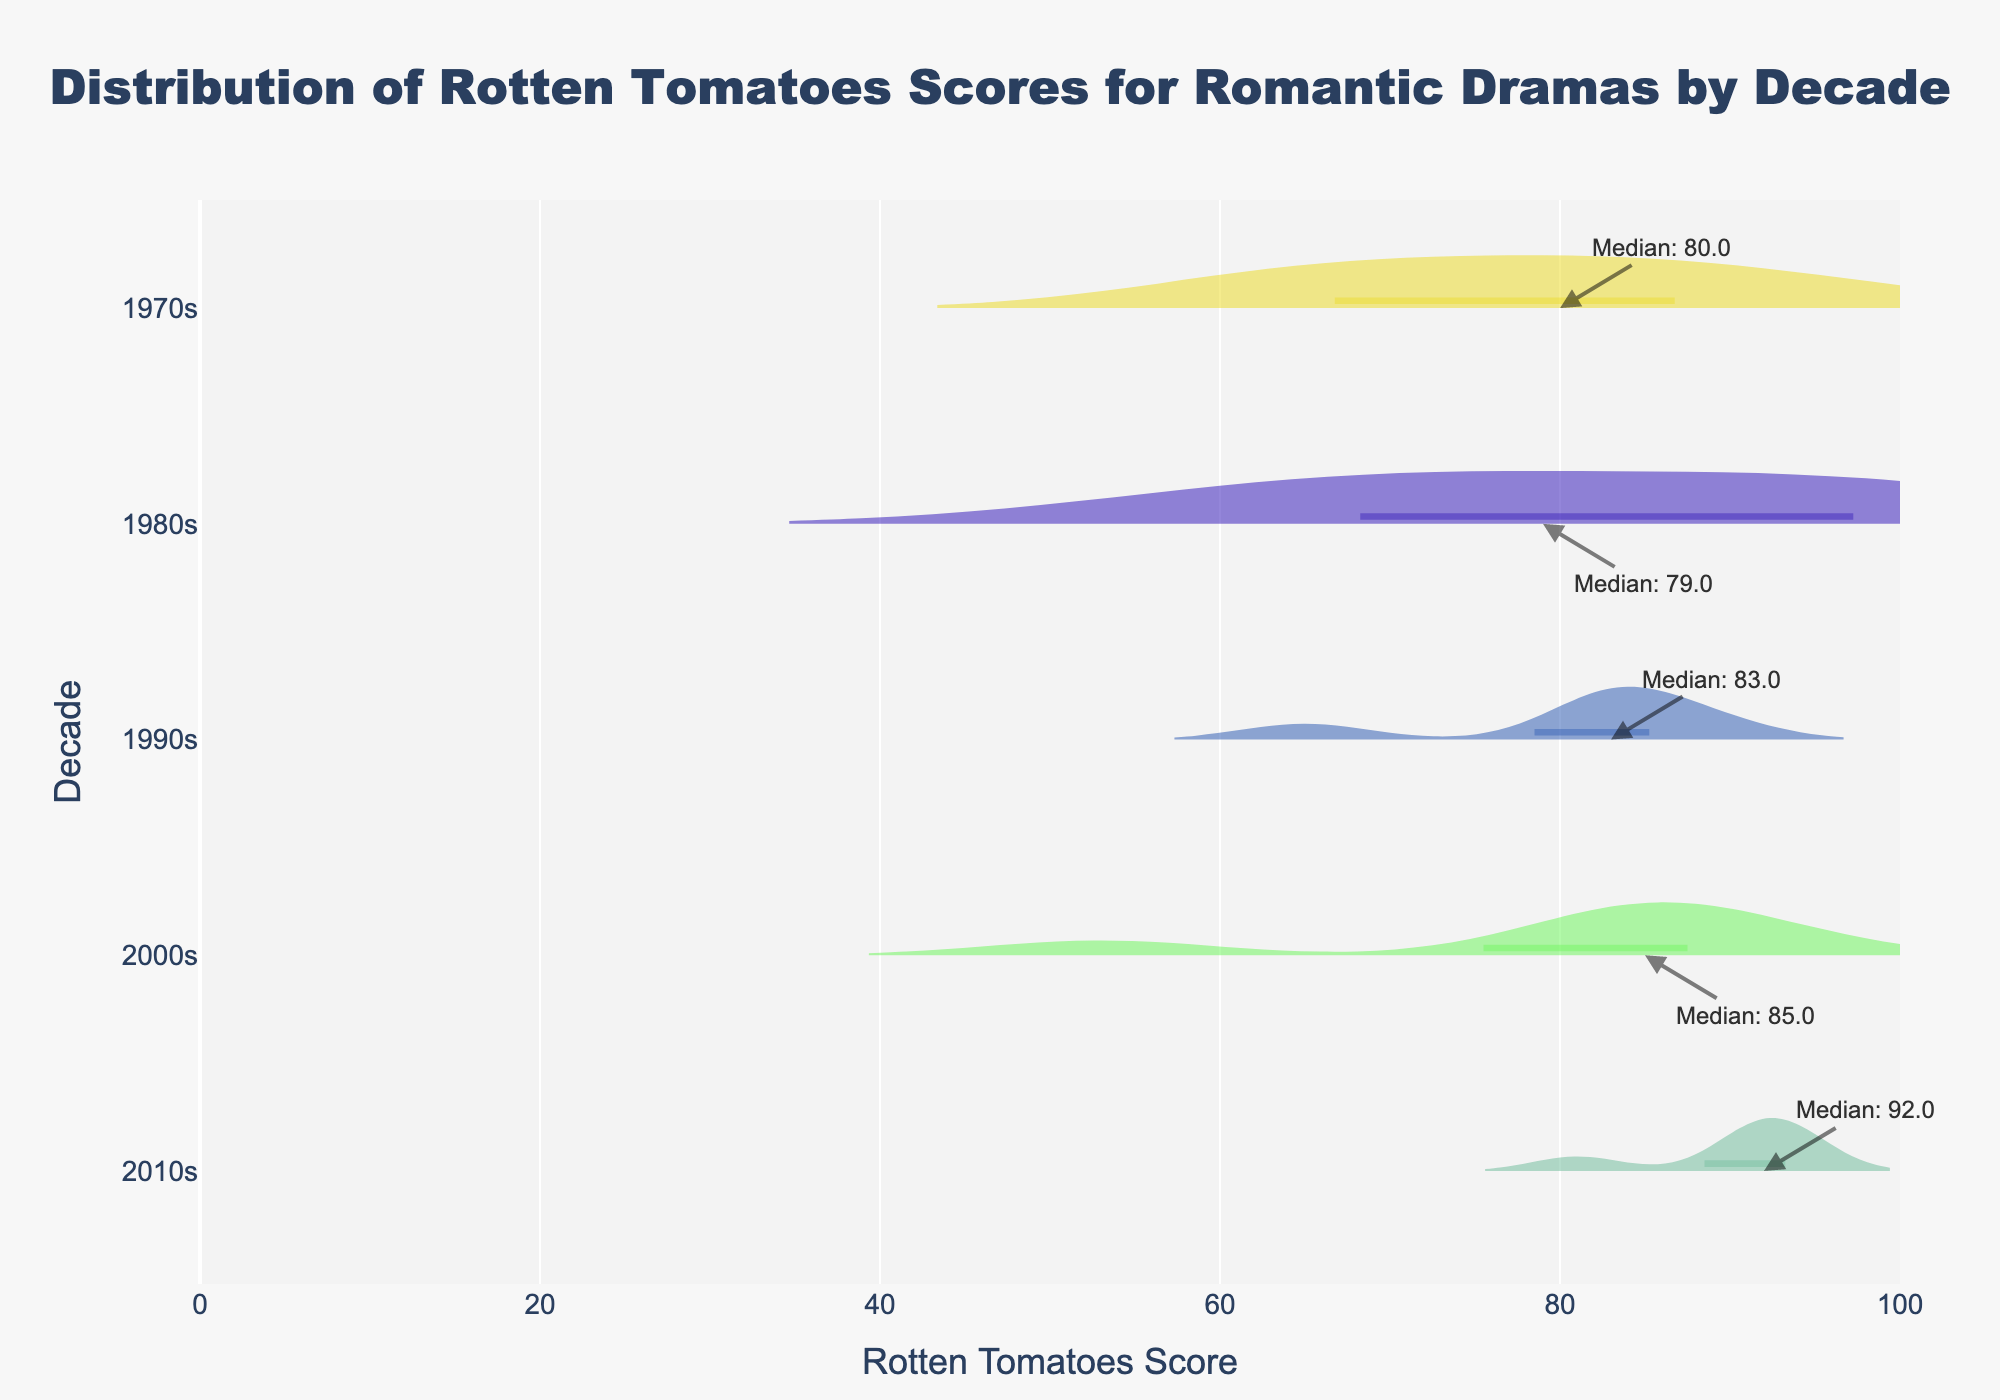How do the Rotten Tomatoes scores vary for each decade? Observing the violin plots for each decade, we can see the distribution and spread of the scores. Each plot shows the range (min to max), density distribution, and median score, which can help identify how scores vary within and between decades.
Answer: Scores vary widely with different patterns of distribution for each decade Which decade has the highest median Rotten Tomatoes score? To determine this, check the annotation for the median on each violin plot. We see that the 1970s has a median of approximately 80, the 1980s about 79, the 1990s around 83, the 2000s approximately 86, and the 2010s around 92.
Answer: 2010s What is the range of Rotten Tomatoes scores for the 2000s? Look at the extent of the 2000s violin plot horizontally. The minimum score for the 2000s is around 53, and the maximum score is about 92. So, the range is 92 - 53.
Answer: 39 Which movie in the 1990s has the highest Rotten Tomatoes score? By examining the extreme points in the 1990s section of the violin plot and correlating it with known scores, we see the highest point is 89, which corresponds to "Titanic."
Answer: Titanic How do the scores of the 1970s compare to the 2010s? Compare the density, spread, and median of the violin plots. The 1970s show a broader spread and slightly lower density than the 2010s. The median in the 1970s is lower at 80 compared to 92 in the 2010s.
Answer: 1970s have lower scores than 2010s Which decade shows the widest spread of scores? Compare the horizontal width of each violin plot. The 1970s and 2000s show significant spreads, but the 1970s appears to have the broadest distribution.
Answer: 1970s What can you infer about the quality of romantic drama movies over time? Observing the trend in median scores and spread over decades, there's an upward trend in median Rotten Tomatoes scores, indicating an improvement in critical reception over time. The 2010s have both a higher median and less variability, suggesting more consistently high-quality movies.
Answer: Quality has increased over time How many scores are above 90 in the 2010s? Look at the points above the 90 mark within the 2010s violin plot. Count the distinct points above this threshold. There are three points above 90.
Answer: 3 